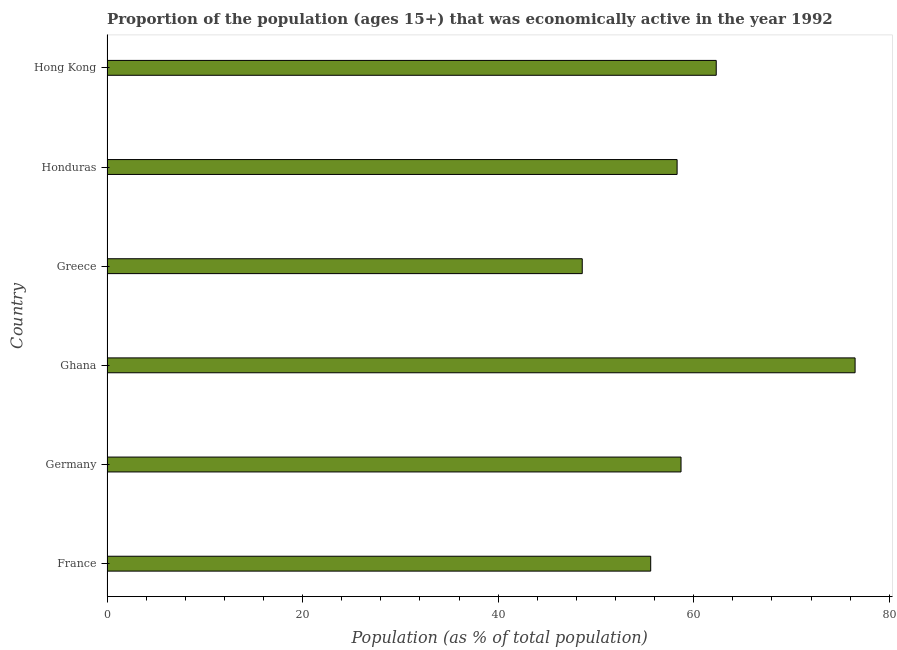What is the title of the graph?
Keep it short and to the point. Proportion of the population (ages 15+) that was economically active in the year 1992. What is the label or title of the X-axis?
Ensure brevity in your answer.  Population (as % of total population). What is the percentage of economically active population in Hong Kong?
Offer a very short reply. 62.3. Across all countries, what is the maximum percentage of economically active population?
Give a very brief answer. 76.5. Across all countries, what is the minimum percentage of economically active population?
Ensure brevity in your answer.  48.6. In which country was the percentage of economically active population maximum?
Keep it short and to the point. Ghana. In which country was the percentage of economically active population minimum?
Offer a very short reply. Greece. What is the sum of the percentage of economically active population?
Your answer should be very brief. 360. What is the average percentage of economically active population per country?
Provide a succinct answer. 60. What is the median percentage of economically active population?
Keep it short and to the point. 58.5. In how many countries, is the percentage of economically active population greater than 24 %?
Your response must be concise. 6. What is the ratio of the percentage of economically active population in Germany to that in Hong Kong?
Offer a very short reply. 0.94. What is the difference between the highest and the second highest percentage of economically active population?
Ensure brevity in your answer.  14.2. What is the difference between the highest and the lowest percentage of economically active population?
Offer a very short reply. 27.9. How many bars are there?
Make the answer very short. 6. How many countries are there in the graph?
Provide a succinct answer. 6. What is the difference between two consecutive major ticks on the X-axis?
Offer a very short reply. 20. Are the values on the major ticks of X-axis written in scientific E-notation?
Give a very brief answer. No. What is the Population (as % of total population) in France?
Offer a terse response. 55.6. What is the Population (as % of total population) of Germany?
Make the answer very short. 58.7. What is the Population (as % of total population) of Ghana?
Your answer should be very brief. 76.5. What is the Population (as % of total population) of Greece?
Your answer should be compact. 48.6. What is the Population (as % of total population) in Honduras?
Your answer should be very brief. 58.3. What is the Population (as % of total population) of Hong Kong?
Give a very brief answer. 62.3. What is the difference between the Population (as % of total population) in France and Ghana?
Your answer should be compact. -20.9. What is the difference between the Population (as % of total population) in France and Greece?
Ensure brevity in your answer.  7. What is the difference between the Population (as % of total population) in France and Honduras?
Offer a very short reply. -2.7. What is the difference between the Population (as % of total population) in Germany and Ghana?
Give a very brief answer. -17.8. What is the difference between the Population (as % of total population) in Germany and Greece?
Provide a succinct answer. 10.1. What is the difference between the Population (as % of total population) in Ghana and Greece?
Your response must be concise. 27.9. What is the difference between the Population (as % of total population) in Greece and Hong Kong?
Keep it short and to the point. -13.7. What is the difference between the Population (as % of total population) in Honduras and Hong Kong?
Keep it short and to the point. -4. What is the ratio of the Population (as % of total population) in France to that in Germany?
Offer a very short reply. 0.95. What is the ratio of the Population (as % of total population) in France to that in Ghana?
Ensure brevity in your answer.  0.73. What is the ratio of the Population (as % of total population) in France to that in Greece?
Your answer should be compact. 1.14. What is the ratio of the Population (as % of total population) in France to that in Honduras?
Ensure brevity in your answer.  0.95. What is the ratio of the Population (as % of total population) in France to that in Hong Kong?
Provide a short and direct response. 0.89. What is the ratio of the Population (as % of total population) in Germany to that in Ghana?
Make the answer very short. 0.77. What is the ratio of the Population (as % of total population) in Germany to that in Greece?
Keep it short and to the point. 1.21. What is the ratio of the Population (as % of total population) in Germany to that in Honduras?
Give a very brief answer. 1.01. What is the ratio of the Population (as % of total population) in Germany to that in Hong Kong?
Keep it short and to the point. 0.94. What is the ratio of the Population (as % of total population) in Ghana to that in Greece?
Give a very brief answer. 1.57. What is the ratio of the Population (as % of total population) in Ghana to that in Honduras?
Offer a very short reply. 1.31. What is the ratio of the Population (as % of total population) in Ghana to that in Hong Kong?
Offer a terse response. 1.23. What is the ratio of the Population (as % of total population) in Greece to that in Honduras?
Make the answer very short. 0.83. What is the ratio of the Population (as % of total population) in Greece to that in Hong Kong?
Provide a short and direct response. 0.78. What is the ratio of the Population (as % of total population) in Honduras to that in Hong Kong?
Make the answer very short. 0.94. 